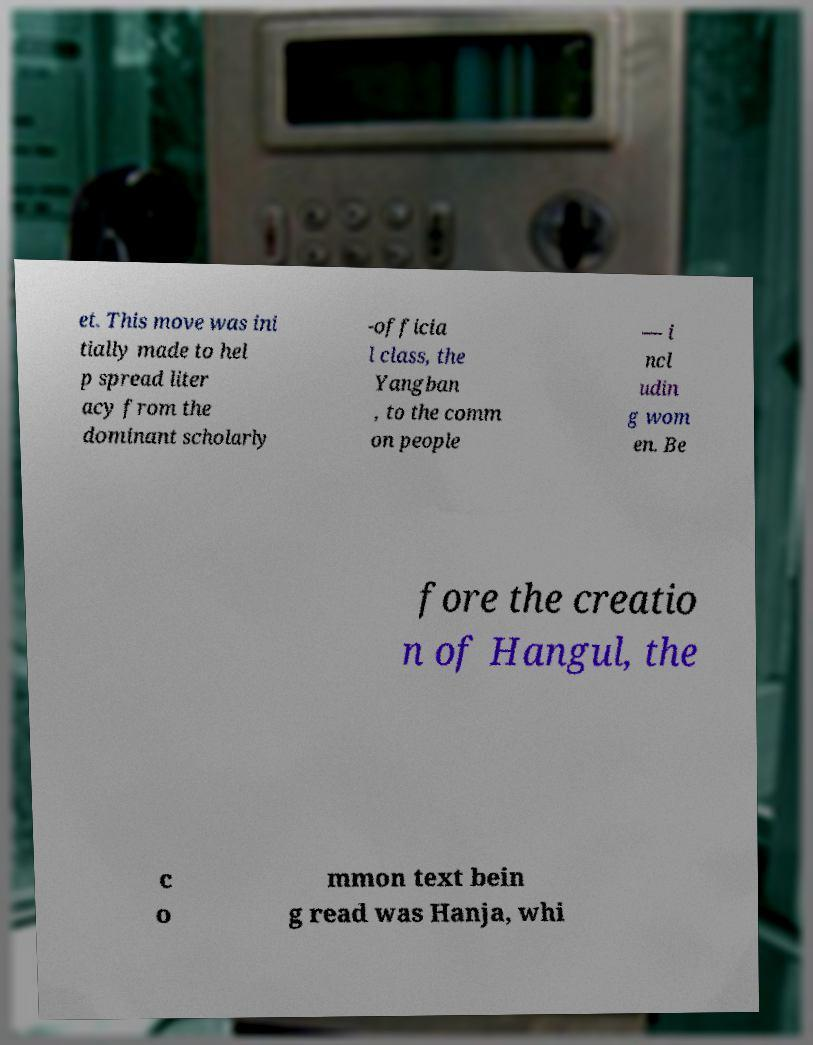I need the written content from this picture converted into text. Can you do that? et. This move was ini tially made to hel p spread liter acy from the dominant scholarly -officia l class, the Yangban , to the comm on people — i ncl udin g wom en. Be fore the creatio n of Hangul, the c o mmon text bein g read was Hanja, whi 